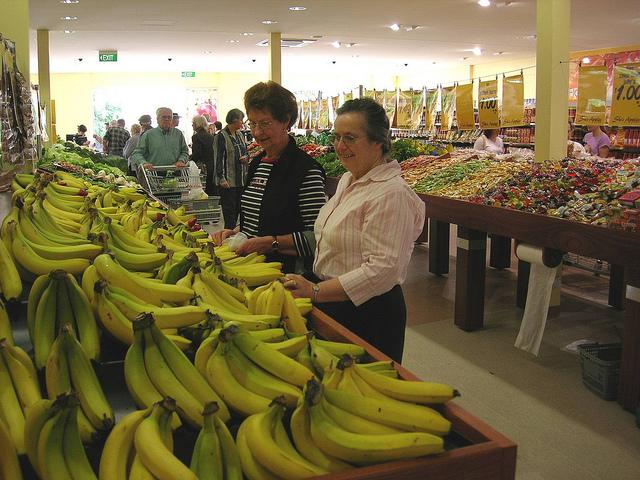Are these people outdoors?
Quick response, please. No. Where are the bags for the food?
Quick response, please. Under table. How many banana bunches are there?
Concise answer only. 45. What color is that fruit on the left?
Answer briefly. Yellow. 